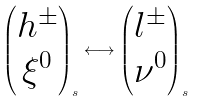<formula> <loc_0><loc_0><loc_500><loc_500>\begin{pmatrix} h ^ { \pm } \\ \xi ^ { 0 } \end{pmatrix} _ { s } \longleftrightarrow \begin{pmatrix} l ^ { \pm } \\ \nu ^ { 0 } \end{pmatrix} _ { s }</formula> 